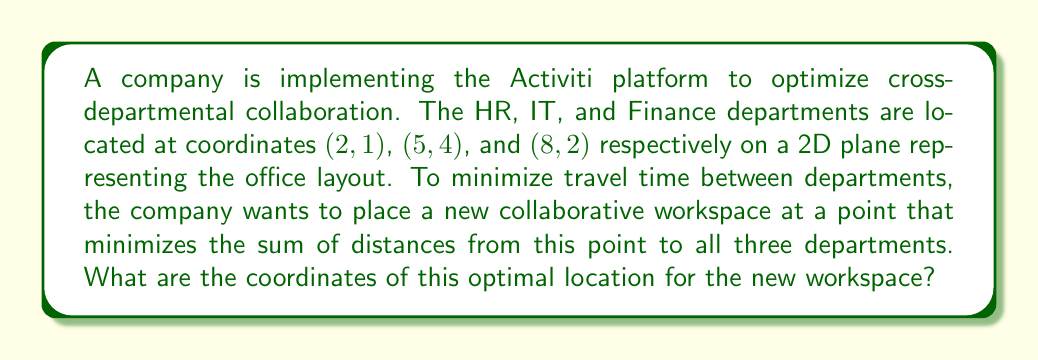What is the answer to this math problem? To solve this problem, we need to find the geometric median of the three points. The geometric median minimizes the sum of distances to all given points. For three points, this is also known as the Fermat point.

1. First, let's check if any angle in the triangle formed by the three points is greater than or equal to 120°. If so, the optimal point would be at the vertex of that angle.

2. To check this, we can calculate the squared distances between the points:
   $d_{HR-IT}^2 = (5-2)^2 + (4-1)^2 = 18$
   $d_{IT-Finance}^2 = (8-5)^2 + (2-4)^2 = 13$
   $d_{Finance-HR}^2 = (8-2)^2 + (2-1)^2 = 37$

3. Using the cosine law, we can calculate the angles:
   $\cos A = \frac{b^2 + c^2 - a^2}{2bc} = \frac{18 + 37 - 13}{2\sqrt{18}\sqrt{37}} \approx 0.9205$
   $A \approx 23.1°$

   Similarly, we can calculate the other angles, which are all less than 120°.

4. Since no angle is greater than or equal to 120°, we need to find the Fermat point. One method to find this point is to use the weighted centroid formula:

   $$x = \frac{\sum_{i=1}^n w_i x_i}{\sum_{i=1}^n w_i}, \quad y = \frac{\sum_{i=1}^n w_i y_i}{\sum_{i=1}^n w_i}$$

   where $(x_i, y_i)$ are the coordinates of each point, and $w_i$ are weights.

5. For the Fermat point, we use weights $w_i = 1$ for all points:

   $$x = \frac{2 + 5 + 8}{3} = 5$$
   $$y = \frac{1 + 4 + 2}{3} = \frac{7}{3} \approx 2.33$$

6. Therefore, the optimal location for the new collaborative workspace is approximately (5, 2.33).
Answer: The optimal coordinates for the new collaborative workspace are (5, 2.33). 